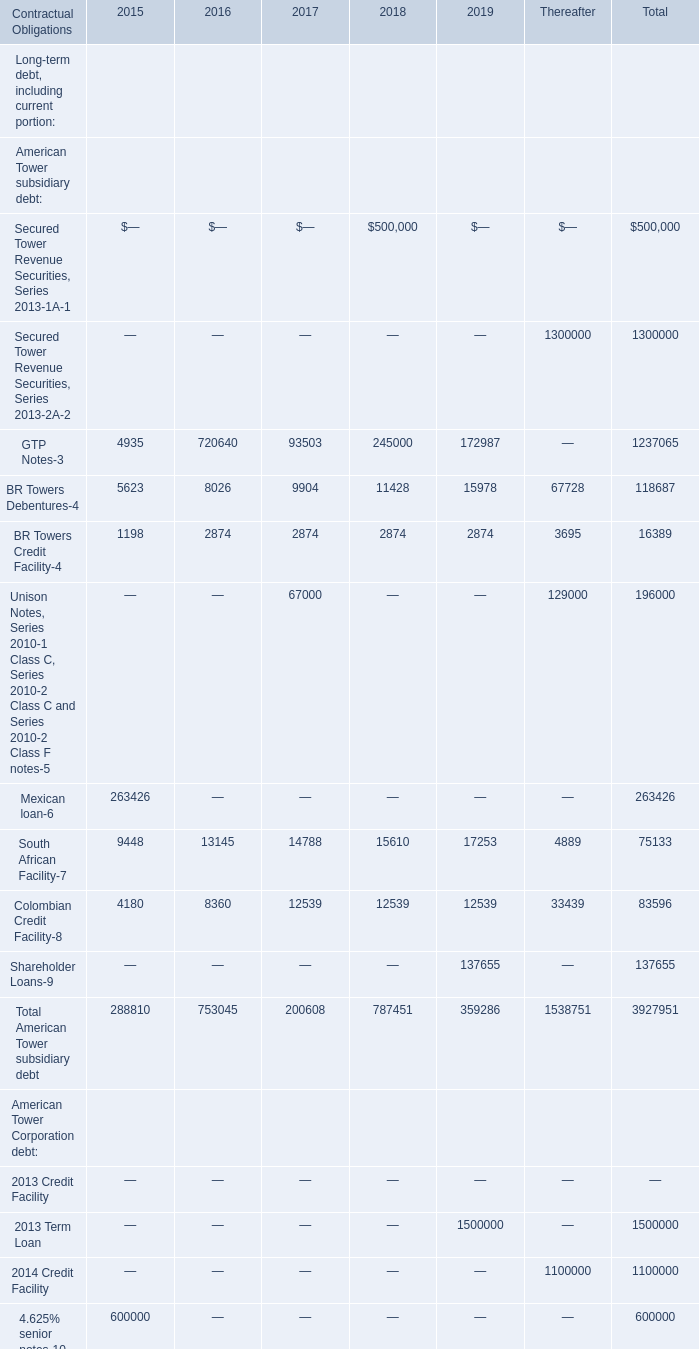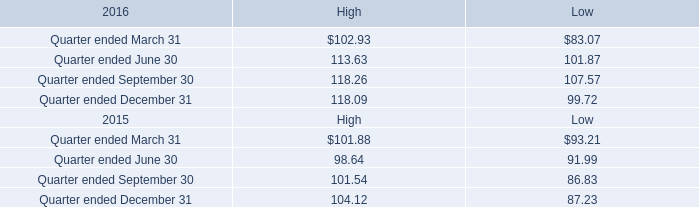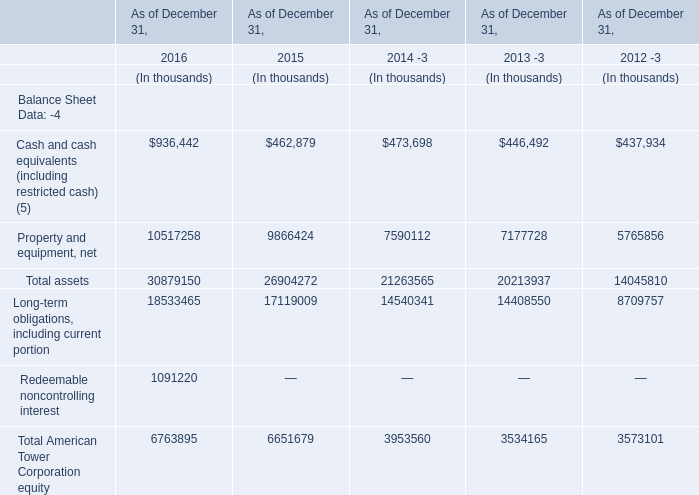Without Secured Tower Revenue Securities, Series 2013-1A-1 and Secured Tower Revenue Securities, Series 2013-2A-2, how much of the Total American Tower subsidiary debt is there in total? 
Computations: ((3927951 - 500000) - 1300000)
Answer: 2127951.0. 